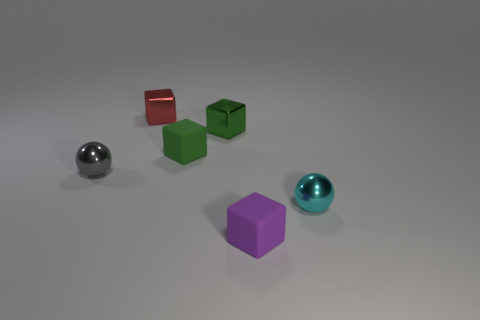Add 1 large things. How many objects exist? 7 Subtract all blocks. How many objects are left? 2 Add 3 large yellow metal cylinders. How many large yellow metal cylinders exist? 3 Subtract 0 blue balls. How many objects are left? 6 Subtract all tiny red metallic blocks. Subtract all large cyan cubes. How many objects are left? 5 Add 4 purple cubes. How many purple cubes are left? 5 